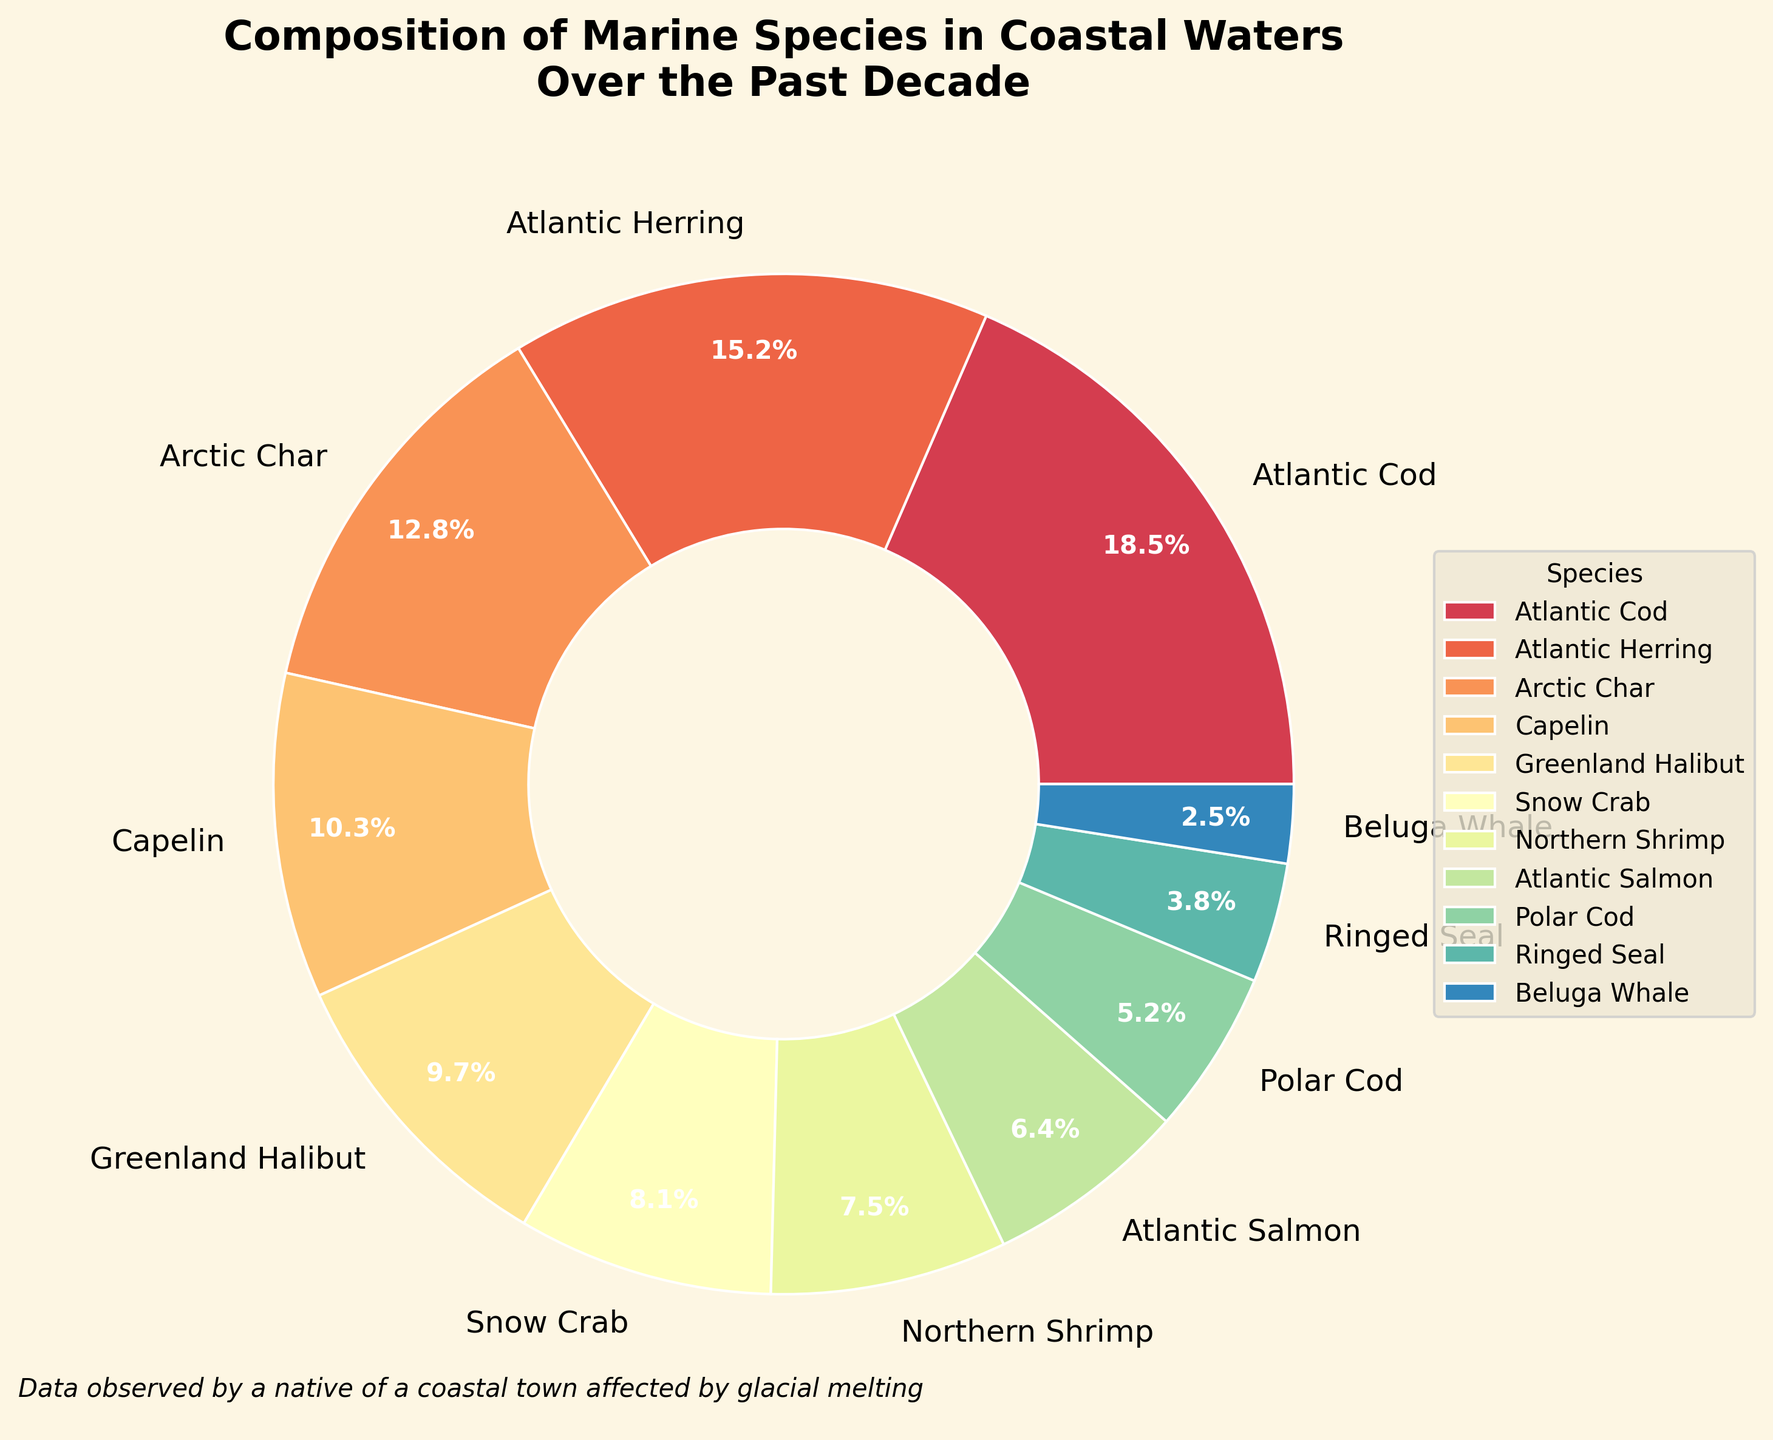What's the most dominant marine species observed in the coastal waters over the past decade? The most dominant marine species is represented by the largest slice in the pie chart, indicated by the highest percentage.
Answer: Atlantic Cod Which species have a combined percentage greater than 30%? To find this, add the percentages of the species and check which combinations exceed 30%. Atlantic Cod (18.5%) and Atlantic Herring (15.2%) sum to 33.7%.
Answer: Atlantic Cod and Atlantic Herring What is the total percentage of Arctic Char, Capelin, and Greenland Halibut combined? Add the percentages of Arctic Char (12.8%), Capelin (10.3%), and Greenland Halibut (9.7%). The total is 12.8 + 10.3 + 9.7 = 32.8%.
Answer: 32.8% Which species has a larger percentage, Atlantic Salmon or Northern Shrimp? Compare the two percentages: Atlantic Salmon (6.4%) vs. Northern Shrimp (7.5%).
Answer: Northern Shrimp Which species proportionally is the smallest according to the pie chart? The smallest slice of the pie chart corresponds to the minimal percentage, which is 2.5%.
Answer: Beluga Whale What is the approximate percentage covered by the top three species in the chart? Sum the percentages of the top three species: Atlantic Cod (18.5%), Atlantic Herring (15.2%), and Arctic Char (12.8%). Their combined percentage is 18.5 + 15.2 + 12.8 = 46.5%.
Answer: 46.5% Which species is represented in the pie slice with a pinkish color? The pinkish color in the pie chart visually corresponds to a specific species. Examine the listed colors and find the pinkish one.
Answer: Ringed Seal By how much does the percentage of Atlantic Cod exceed that of Polar Cod? Subtract the percentage of Polar Cod (5.2%) from Atlantic Cod (18.5%). The difference is 18.5 - 5.2 = 13.3%.
Answer: 13.3% What percentage of marine species is made up by both Snow Crab and Ringed Seal? Add the percentages of Snow Crab (8.1%) and Ringed Seal (3.8%). Their combined percentage is 8.1 + 3.8 = 11.9%.
Answer: 11.9% Among the marine species, which ones have a percentage above 10% and what are their combined percentage? Identify species with percentages above 10%: Atlantic Cod (18.5%), Atlantic Herring (15.2%), Arctic Char (12.8%), and Capelin (10.3%). Their combined percentage is 18.5 + 15.2 + 12.8 + 10.3 = 56.8%.
Answer: Atlantic Cod, Atlantic Herring, Arctic Char, Capelin; 56.8% 